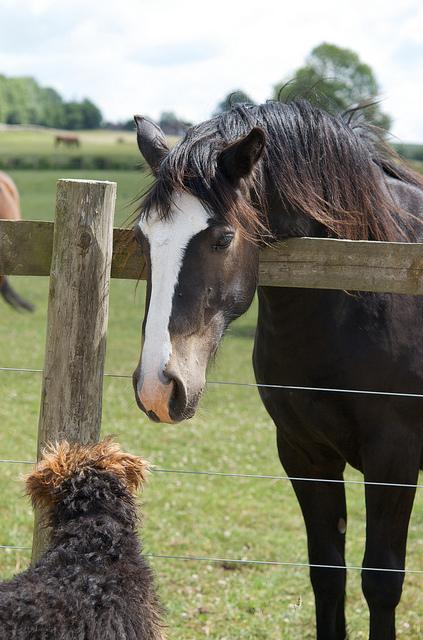Do they kiss?
Concise answer only. No. Is the horse wearing a saddle?
Short answer required. No. Is the horse afraid of the dog?
Give a very brief answer. No. 